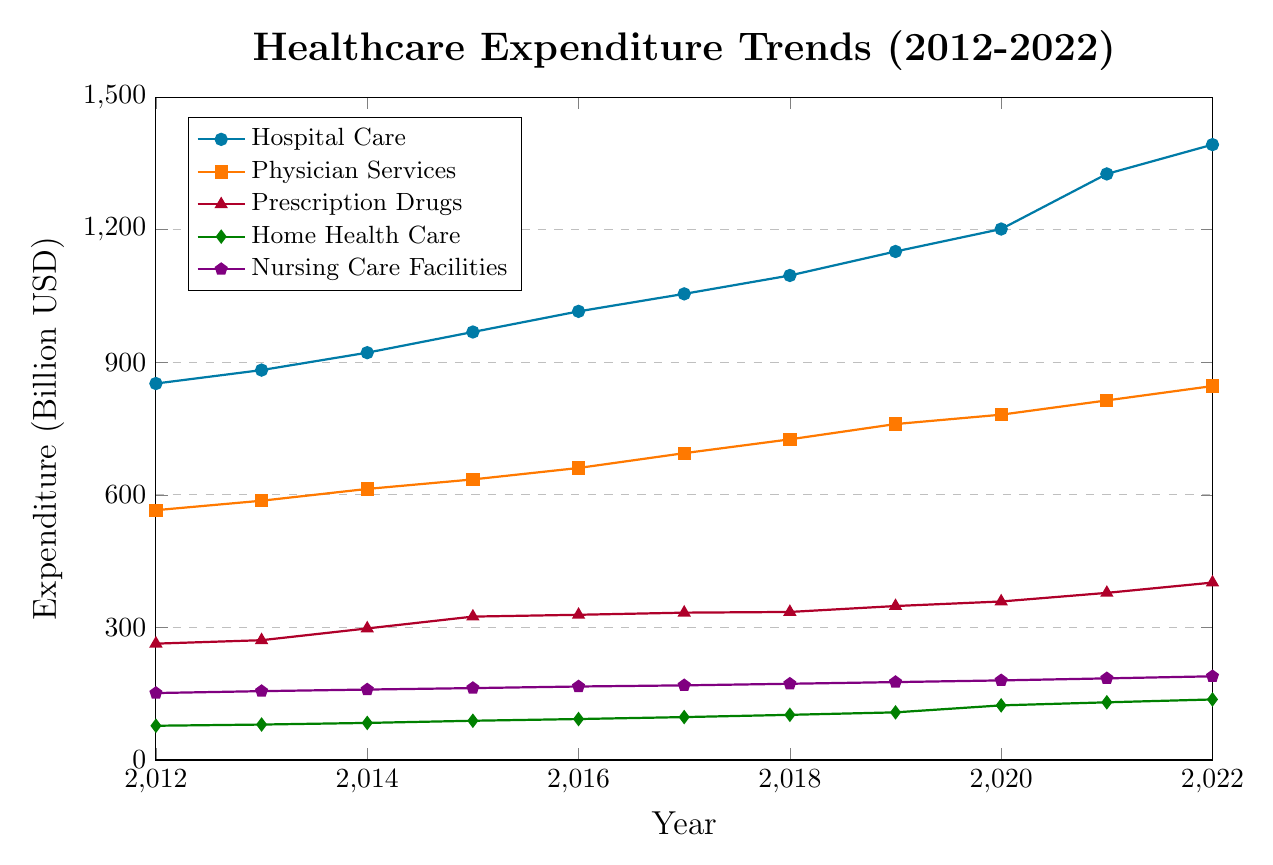What category had the highest expenditure in 2022? By observing the 2022 data points, the category with the highest expenditure is marked by the highest point on the y-axis among the categories. The highest point corresponds to Hospital Care.
Answer: Hospital Care How much did expenditure on Home Health Care increase from 2012 to 2022? To find the increase, subtract the expenditure in 2012 from the expenditure in 2022 for Home Health Care. This is 137.0 - 77.5.
Answer: 59.5 billion USD Which category had the smallest expenditure in 2017? Look at the data points for 2017 and identify the category with the lowest point on the y-axis. The smallest expenditure in 2017 is for Home Health Care.
Answer: Home Health Care By how much did the expenditure on Prescription Drugs increase between 2016 and 2022? Calculate the difference between the expenditure in 2022 and 2016 for Prescription Drugs. This is 401.5 - 328.6.
Answer: 72.9 billion USD In what year did Physician Services expenditure exceed 700 billion USD for the first time? Check the data points and find the first year when Physician Services expenditure is above 700. That year is 2018.
Answer: 2018 Calculate the average annual expenditure on Nursing Care Facilities from 2012 to 2022. Sum the expenditures from 2012 to 2022 for Nursing Care Facilities and then divide by the number of years (11 years). This is (151.5 + 155.8 + 159.4 + 162.7 + 166.3 + 168.9 + 172.5 + 176.3 + 180.1 + 184.7 + 189.4) / 11 = 168.0.
Answer: 168.0 billion USD Which category showed the greatest percentage increase in expenditure from 2012 to 2022? Calculate the percentage increase for each category: 
\[ 
\text{Hospital Care} = \left( \frac{1392.5 - 851.9}{851.9} \right) \times 100 = 63.4\%
\]
\[ 
\text{Physician Services} = \left( \frac{846.2 - 565.3}{565.3} \right) \times 100 = 49.7\%
\]
\[ 
\text{Prescription Drugs} = \left( \frac{401.5 - 263.3}{263.3} \right) \times 100 = 52.5\%
\]
\[ 
\text{Home Health Care} = \left( \frac{137.0 - 77.5}{77.5} \right) \times 100 = 76.8\%
\]
\[ 
\text{Nursing Care Facilities} = \left( \frac{189.4 - 151.5}{151.5} \right) \times 100 = 25.0\%
\]
The highest percentage increase is for Home Health Care.
Answer: Home Health Care 